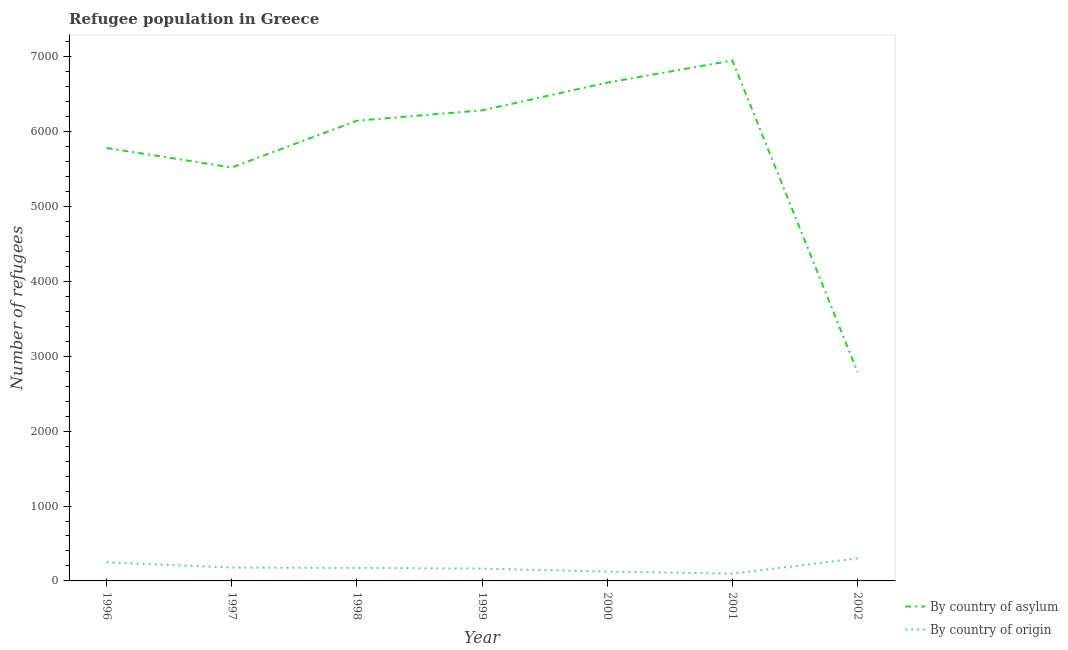Is the number of lines equal to the number of legend labels?
Make the answer very short. Yes. What is the number of refugees by country of origin in 1998?
Offer a very short reply. 174. Across all years, what is the maximum number of refugees by country of asylum?
Keep it short and to the point. 6948. Across all years, what is the minimum number of refugees by country of origin?
Your answer should be compact. 97. What is the total number of refugees by country of origin in the graph?
Provide a short and direct response. 1289. What is the difference between the number of refugees by country of asylum in 2001 and that in 2002?
Provide a short and direct response. 4160. What is the difference between the number of refugees by country of asylum in 1996 and the number of refugees by country of origin in 2002?
Offer a terse response. 5479. What is the average number of refugees by country of origin per year?
Your answer should be compact. 184.14. In the year 1998, what is the difference between the number of refugees by country of asylum and number of refugees by country of origin?
Keep it short and to the point. 5971. What is the ratio of the number of refugees by country of asylum in 2001 to that in 2002?
Offer a terse response. 2.49. What is the difference between the highest and the second highest number of refugees by country of asylum?
Make the answer very short. 295. What is the difference between the highest and the lowest number of refugees by country of origin?
Your answer should be very brief. 204. Is the sum of the number of refugees by country of origin in 1998 and 1999 greater than the maximum number of refugees by country of asylum across all years?
Your answer should be very brief. No. Is the number of refugees by country of asylum strictly greater than the number of refugees by country of origin over the years?
Keep it short and to the point. Yes. Is the number of refugees by country of asylum strictly less than the number of refugees by country of origin over the years?
Provide a short and direct response. No. How many lines are there?
Your response must be concise. 2. What is the difference between two consecutive major ticks on the Y-axis?
Provide a succinct answer. 1000. Does the graph contain any zero values?
Give a very brief answer. No. Where does the legend appear in the graph?
Your answer should be compact. Bottom right. What is the title of the graph?
Ensure brevity in your answer.  Refugee population in Greece. Does "Current US$" appear as one of the legend labels in the graph?
Provide a short and direct response. No. What is the label or title of the X-axis?
Offer a very short reply. Year. What is the label or title of the Y-axis?
Ensure brevity in your answer.  Number of refugees. What is the Number of refugees of By country of asylum in 1996?
Your response must be concise. 5780. What is the Number of refugees of By country of origin in 1996?
Give a very brief answer. 250. What is the Number of refugees of By country of asylum in 1997?
Your response must be concise. 5520. What is the Number of refugees of By country of origin in 1997?
Keep it short and to the point. 178. What is the Number of refugees of By country of asylum in 1998?
Provide a short and direct response. 6145. What is the Number of refugees of By country of origin in 1998?
Give a very brief answer. 174. What is the Number of refugees in By country of asylum in 1999?
Offer a very short reply. 6283. What is the Number of refugees of By country of origin in 1999?
Your answer should be compact. 164. What is the Number of refugees of By country of asylum in 2000?
Keep it short and to the point. 6653. What is the Number of refugees in By country of origin in 2000?
Ensure brevity in your answer.  125. What is the Number of refugees of By country of asylum in 2001?
Your response must be concise. 6948. What is the Number of refugees of By country of origin in 2001?
Ensure brevity in your answer.  97. What is the Number of refugees in By country of asylum in 2002?
Ensure brevity in your answer.  2788. What is the Number of refugees in By country of origin in 2002?
Keep it short and to the point. 301. Across all years, what is the maximum Number of refugees of By country of asylum?
Offer a terse response. 6948. Across all years, what is the maximum Number of refugees in By country of origin?
Provide a short and direct response. 301. Across all years, what is the minimum Number of refugees in By country of asylum?
Offer a terse response. 2788. Across all years, what is the minimum Number of refugees in By country of origin?
Your response must be concise. 97. What is the total Number of refugees of By country of asylum in the graph?
Ensure brevity in your answer.  4.01e+04. What is the total Number of refugees in By country of origin in the graph?
Offer a very short reply. 1289. What is the difference between the Number of refugees in By country of asylum in 1996 and that in 1997?
Keep it short and to the point. 260. What is the difference between the Number of refugees in By country of asylum in 1996 and that in 1998?
Give a very brief answer. -365. What is the difference between the Number of refugees in By country of asylum in 1996 and that in 1999?
Your response must be concise. -503. What is the difference between the Number of refugees of By country of asylum in 1996 and that in 2000?
Your response must be concise. -873. What is the difference between the Number of refugees in By country of origin in 1996 and that in 2000?
Make the answer very short. 125. What is the difference between the Number of refugees of By country of asylum in 1996 and that in 2001?
Your response must be concise. -1168. What is the difference between the Number of refugees in By country of origin in 1996 and that in 2001?
Give a very brief answer. 153. What is the difference between the Number of refugees in By country of asylum in 1996 and that in 2002?
Ensure brevity in your answer.  2992. What is the difference between the Number of refugees of By country of origin in 1996 and that in 2002?
Provide a succinct answer. -51. What is the difference between the Number of refugees of By country of asylum in 1997 and that in 1998?
Make the answer very short. -625. What is the difference between the Number of refugees in By country of asylum in 1997 and that in 1999?
Provide a short and direct response. -763. What is the difference between the Number of refugees in By country of asylum in 1997 and that in 2000?
Provide a short and direct response. -1133. What is the difference between the Number of refugees in By country of asylum in 1997 and that in 2001?
Ensure brevity in your answer.  -1428. What is the difference between the Number of refugees in By country of origin in 1997 and that in 2001?
Your answer should be very brief. 81. What is the difference between the Number of refugees of By country of asylum in 1997 and that in 2002?
Your answer should be compact. 2732. What is the difference between the Number of refugees in By country of origin in 1997 and that in 2002?
Give a very brief answer. -123. What is the difference between the Number of refugees of By country of asylum in 1998 and that in 1999?
Provide a short and direct response. -138. What is the difference between the Number of refugees of By country of origin in 1998 and that in 1999?
Keep it short and to the point. 10. What is the difference between the Number of refugees of By country of asylum in 1998 and that in 2000?
Ensure brevity in your answer.  -508. What is the difference between the Number of refugees in By country of asylum in 1998 and that in 2001?
Offer a terse response. -803. What is the difference between the Number of refugees of By country of asylum in 1998 and that in 2002?
Give a very brief answer. 3357. What is the difference between the Number of refugees in By country of origin in 1998 and that in 2002?
Provide a short and direct response. -127. What is the difference between the Number of refugees of By country of asylum in 1999 and that in 2000?
Offer a terse response. -370. What is the difference between the Number of refugees in By country of origin in 1999 and that in 2000?
Offer a terse response. 39. What is the difference between the Number of refugees in By country of asylum in 1999 and that in 2001?
Keep it short and to the point. -665. What is the difference between the Number of refugees of By country of asylum in 1999 and that in 2002?
Keep it short and to the point. 3495. What is the difference between the Number of refugees of By country of origin in 1999 and that in 2002?
Your answer should be very brief. -137. What is the difference between the Number of refugees in By country of asylum in 2000 and that in 2001?
Provide a succinct answer. -295. What is the difference between the Number of refugees of By country of origin in 2000 and that in 2001?
Your answer should be very brief. 28. What is the difference between the Number of refugees in By country of asylum in 2000 and that in 2002?
Keep it short and to the point. 3865. What is the difference between the Number of refugees in By country of origin in 2000 and that in 2002?
Provide a succinct answer. -176. What is the difference between the Number of refugees in By country of asylum in 2001 and that in 2002?
Ensure brevity in your answer.  4160. What is the difference between the Number of refugees of By country of origin in 2001 and that in 2002?
Offer a very short reply. -204. What is the difference between the Number of refugees in By country of asylum in 1996 and the Number of refugees in By country of origin in 1997?
Your response must be concise. 5602. What is the difference between the Number of refugees in By country of asylum in 1996 and the Number of refugees in By country of origin in 1998?
Provide a short and direct response. 5606. What is the difference between the Number of refugees in By country of asylum in 1996 and the Number of refugees in By country of origin in 1999?
Provide a short and direct response. 5616. What is the difference between the Number of refugees of By country of asylum in 1996 and the Number of refugees of By country of origin in 2000?
Your answer should be very brief. 5655. What is the difference between the Number of refugees of By country of asylum in 1996 and the Number of refugees of By country of origin in 2001?
Your response must be concise. 5683. What is the difference between the Number of refugees of By country of asylum in 1996 and the Number of refugees of By country of origin in 2002?
Offer a very short reply. 5479. What is the difference between the Number of refugees in By country of asylum in 1997 and the Number of refugees in By country of origin in 1998?
Offer a very short reply. 5346. What is the difference between the Number of refugees of By country of asylum in 1997 and the Number of refugees of By country of origin in 1999?
Provide a short and direct response. 5356. What is the difference between the Number of refugees of By country of asylum in 1997 and the Number of refugees of By country of origin in 2000?
Give a very brief answer. 5395. What is the difference between the Number of refugees of By country of asylum in 1997 and the Number of refugees of By country of origin in 2001?
Provide a short and direct response. 5423. What is the difference between the Number of refugees in By country of asylum in 1997 and the Number of refugees in By country of origin in 2002?
Your response must be concise. 5219. What is the difference between the Number of refugees of By country of asylum in 1998 and the Number of refugees of By country of origin in 1999?
Your answer should be compact. 5981. What is the difference between the Number of refugees of By country of asylum in 1998 and the Number of refugees of By country of origin in 2000?
Keep it short and to the point. 6020. What is the difference between the Number of refugees in By country of asylum in 1998 and the Number of refugees in By country of origin in 2001?
Provide a short and direct response. 6048. What is the difference between the Number of refugees of By country of asylum in 1998 and the Number of refugees of By country of origin in 2002?
Your response must be concise. 5844. What is the difference between the Number of refugees of By country of asylum in 1999 and the Number of refugees of By country of origin in 2000?
Give a very brief answer. 6158. What is the difference between the Number of refugees in By country of asylum in 1999 and the Number of refugees in By country of origin in 2001?
Provide a succinct answer. 6186. What is the difference between the Number of refugees of By country of asylum in 1999 and the Number of refugees of By country of origin in 2002?
Offer a terse response. 5982. What is the difference between the Number of refugees of By country of asylum in 2000 and the Number of refugees of By country of origin in 2001?
Your response must be concise. 6556. What is the difference between the Number of refugees of By country of asylum in 2000 and the Number of refugees of By country of origin in 2002?
Your response must be concise. 6352. What is the difference between the Number of refugees of By country of asylum in 2001 and the Number of refugees of By country of origin in 2002?
Offer a very short reply. 6647. What is the average Number of refugees of By country of asylum per year?
Your answer should be compact. 5731. What is the average Number of refugees of By country of origin per year?
Make the answer very short. 184.14. In the year 1996, what is the difference between the Number of refugees of By country of asylum and Number of refugees of By country of origin?
Provide a succinct answer. 5530. In the year 1997, what is the difference between the Number of refugees in By country of asylum and Number of refugees in By country of origin?
Offer a terse response. 5342. In the year 1998, what is the difference between the Number of refugees of By country of asylum and Number of refugees of By country of origin?
Your response must be concise. 5971. In the year 1999, what is the difference between the Number of refugees in By country of asylum and Number of refugees in By country of origin?
Provide a short and direct response. 6119. In the year 2000, what is the difference between the Number of refugees in By country of asylum and Number of refugees in By country of origin?
Provide a short and direct response. 6528. In the year 2001, what is the difference between the Number of refugees in By country of asylum and Number of refugees in By country of origin?
Your response must be concise. 6851. In the year 2002, what is the difference between the Number of refugees in By country of asylum and Number of refugees in By country of origin?
Give a very brief answer. 2487. What is the ratio of the Number of refugees of By country of asylum in 1996 to that in 1997?
Your response must be concise. 1.05. What is the ratio of the Number of refugees in By country of origin in 1996 to that in 1997?
Provide a short and direct response. 1.4. What is the ratio of the Number of refugees in By country of asylum in 1996 to that in 1998?
Offer a very short reply. 0.94. What is the ratio of the Number of refugees of By country of origin in 1996 to that in 1998?
Offer a very short reply. 1.44. What is the ratio of the Number of refugees of By country of asylum in 1996 to that in 1999?
Your answer should be very brief. 0.92. What is the ratio of the Number of refugees in By country of origin in 1996 to that in 1999?
Your answer should be compact. 1.52. What is the ratio of the Number of refugees of By country of asylum in 1996 to that in 2000?
Your answer should be compact. 0.87. What is the ratio of the Number of refugees of By country of asylum in 1996 to that in 2001?
Provide a succinct answer. 0.83. What is the ratio of the Number of refugees in By country of origin in 1996 to that in 2001?
Make the answer very short. 2.58. What is the ratio of the Number of refugees in By country of asylum in 1996 to that in 2002?
Your response must be concise. 2.07. What is the ratio of the Number of refugees of By country of origin in 1996 to that in 2002?
Give a very brief answer. 0.83. What is the ratio of the Number of refugees in By country of asylum in 1997 to that in 1998?
Your answer should be very brief. 0.9. What is the ratio of the Number of refugees in By country of asylum in 1997 to that in 1999?
Make the answer very short. 0.88. What is the ratio of the Number of refugees of By country of origin in 1997 to that in 1999?
Keep it short and to the point. 1.09. What is the ratio of the Number of refugees of By country of asylum in 1997 to that in 2000?
Keep it short and to the point. 0.83. What is the ratio of the Number of refugees in By country of origin in 1997 to that in 2000?
Provide a short and direct response. 1.42. What is the ratio of the Number of refugees in By country of asylum in 1997 to that in 2001?
Make the answer very short. 0.79. What is the ratio of the Number of refugees in By country of origin in 1997 to that in 2001?
Your answer should be compact. 1.84. What is the ratio of the Number of refugees in By country of asylum in 1997 to that in 2002?
Your response must be concise. 1.98. What is the ratio of the Number of refugees of By country of origin in 1997 to that in 2002?
Provide a short and direct response. 0.59. What is the ratio of the Number of refugees of By country of origin in 1998 to that in 1999?
Offer a terse response. 1.06. What is the ratio of the Number of refugees of By country of asylum in 1998 to that in 2000?
Give a very brief answer. 0.92. What is the ratio of the Number of refugees in By country of origin in 1998 to that in 2000?
Give a very brief answer. 1.39. What is the ratio of the Number of refugees of By country of asylum in 1998 to that in 2001?
Provide a succinct answer. 0.88. What is the ratio of the Number of refugees of By country of origin in 1998 to that in 2001?
Provide a short and direct response. 1.79. What is the ratio of the Number of refugees of By country of asylum in 1998 to that in 2002?
Offer a terse response. 2.2. What is the ratio of the Number of refugees of By country of origin in 1998 to that in 2002?
Offer a terse response. 0.58. What is the ratio of the Number of refugees in By country of asylum in 1999 to that in 2000?
Give a very brief answer. 0.94. What is the ratio of the Number of refugees of By country of origin in 1999 to that in 2000?
Give a very brief answer. 1.31. What is the ratio of the Number of refugees of By country of asylum in 1999 to that in 2001?
Your answer should be very brief. 0.9. What is the ratio of the Number of refugees in By country of origin in 1999 to that in 2001?
Make the answer very short. 1.69. What is the ratio of the Number of refugees in By country of asylum in 1999 to that in 2002?
Your answer should be very brief. 2.25. What is the ratio of the Number of refugees of By country of origin in 1999 to that in 2002?
Offer a terse response. 0.54. What is the ratio of the Number of refugees of By country of asylum in 2000 to that in 2001?
Give a very brief answer. 0.96. What is the ratio of the Number of refugees of By country of origin in 2000 to that in 2001?
Offer a terse response. 1.29. What is the ratio of the Number of refugees of By country of asylum in 2000 to that in 2002?
Ensure brevity in your answer.  2.39. What is the ratio of the Number of refugees of By country of origin in 2000 to that in 2002?
Make the answer very short. 0.42. What is the ratio of the Number of refugees in By country of asylum in 2001 to that in 2002?
Provide a succinct answer. 2.49. What is the ratio of the Number of refugees of By country of origin in 2001 to that in 2002?
Your response must be concise. 0.32. What is the difference between the highest and the second highest Number of refugees of By country of asylum?
Provide a short and direct response. 295. What is the difference between the highest and the second highest Number of refugees in By country of origin?
Provide a succinct answer. 51. What is the difference between the highest and the lowest Number of refugees of By country of asylum?
Your answer should be compact. 4160. What is the difference between the highest and the lowest Number of refugees of By country of origin?
Your answer should be compact. 204. 